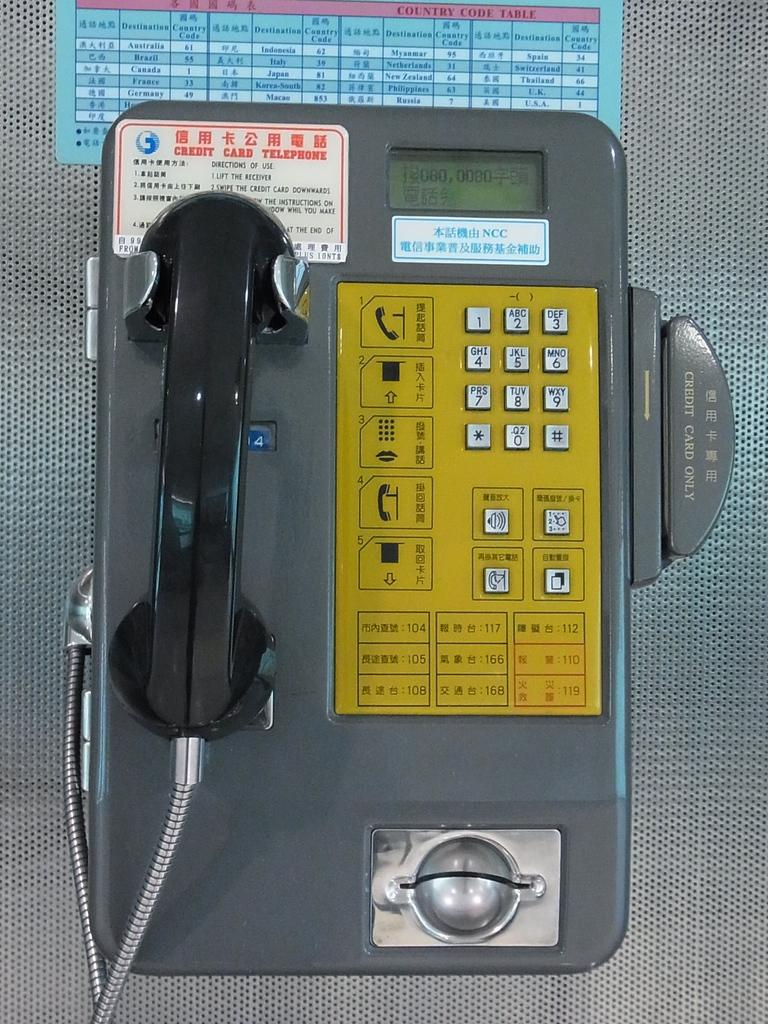What type of communication device is present in the image? There is a payphone in the image. What is attached to an object in the image? A board is attached to an object in the image. What features does the payphone have? The payphone has buttons, stickers, a display screen, and a handset. What type of coast can be seen in the image? There is no coast present in the image; it features a payphone and a board. What plot is being developed in the image? The image does not depict a plot or storyline; it is a static representation of a payphone and a board. 